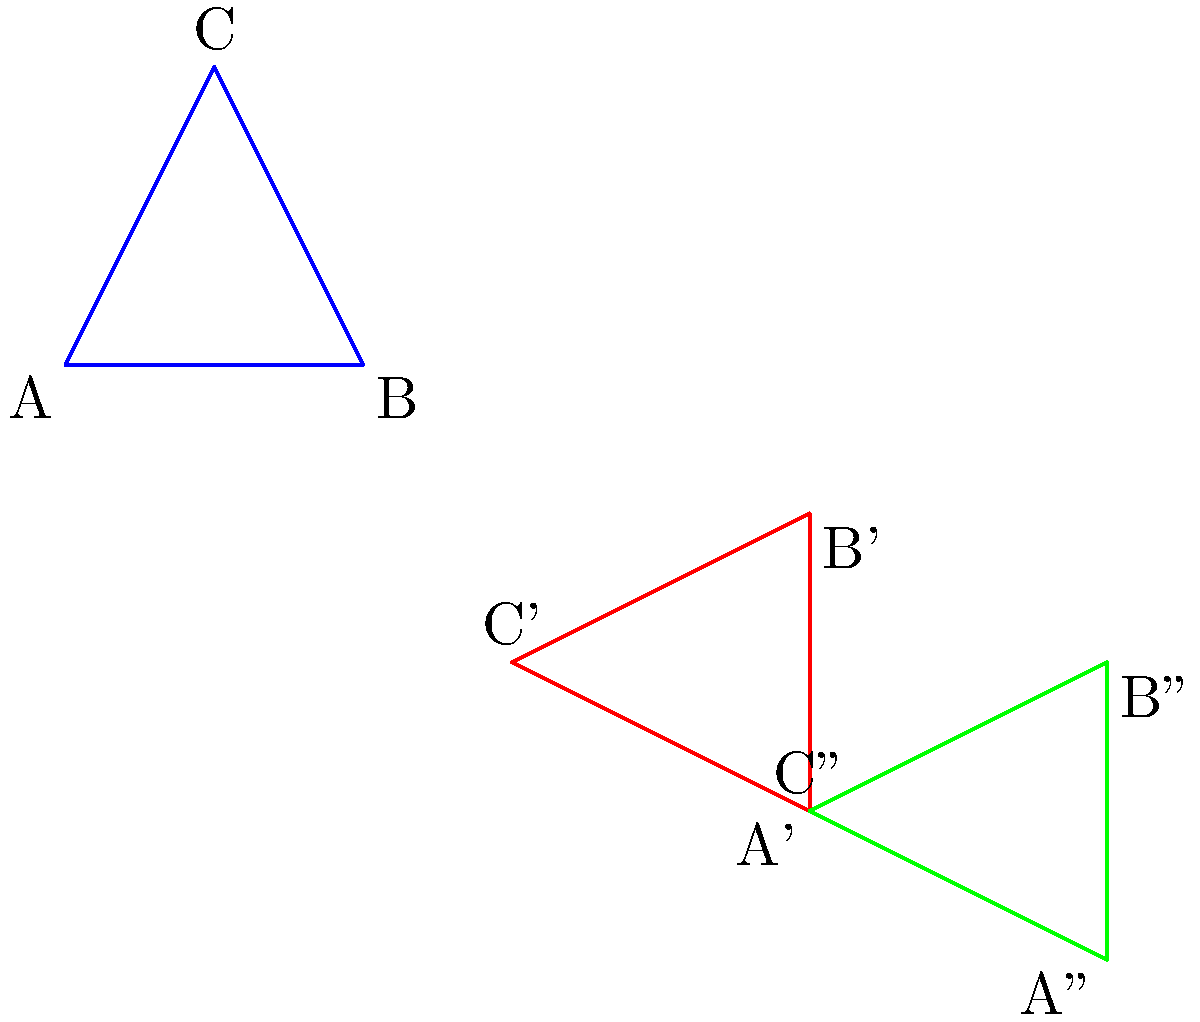In the context of teaching digital literacy to seniors, consider using this geometry example to explain transformations in digital image editing. Triangle ABC undergoes two transformations: first, a 90-degree clockwise rotation around the point (4,1), resulting in A'B'C', and then a translation of 2 units right and 1 unit down, resulting in A''B''C''. What is the final position of point C after these transformations? To find the final position of point C, we need to follow these steps:

1. Initial position of C: (1,2)

2. Rotation:
   - Center of rotation: (4,1)
   - Angle: 90 degrees clockwise
   - To rotate a point (x,y) around (a,b) by θ degrees:
     $x' = (x-a)\cos θ - (y-b)\sin θ + a$
     $y' = (x-a)\sin θ + (y-b)\cos θ + b$
   - For C(1,2) around (4,1) by 90° clockwise:
     $x' = (1-4)\cos(-90°) - (2-1)\sin(-90°) + 4 = 3\cdot0 - (-1)\cdot1 + 4 = 5$
     $y' = (1-4)\sin(-90°) + (2-1)\cos(-90°) + 1 = 3\cdot(-1) - (-1)\cdot0 + 1 = -2$
   - C' position after rotation: (5,-2)

3. Translation:
   - Shift: 2 units right, 1 unit down
   - Add 2 to x-coordinate: 5 + 2 = 7
   - Subtract 1 from y-coordinate: -2 - 1 = -3

Therefore, the final position of C'' is (7,-3).
Answer: (7,-3) 